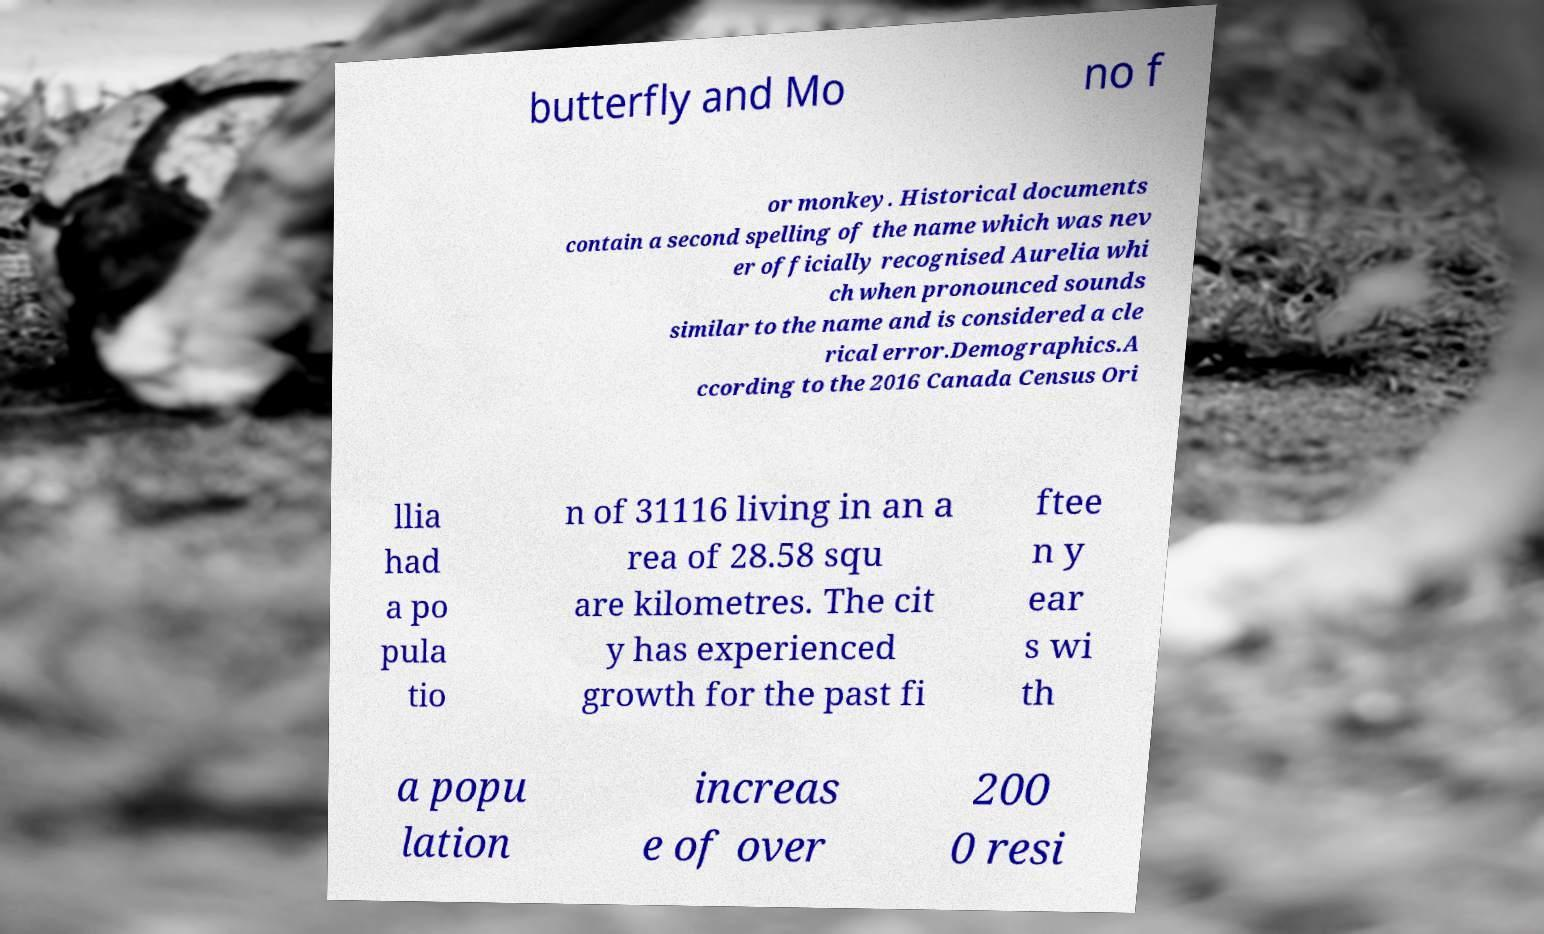There's text embedded in this image that I need extracted. Can you transcribe it verbatim? butterfly and Mo no f or monkey. Historical documents contain a second spelling of the name which was nev er officially recognised Aurelia whi ch when pronounced sounds similar to the name and is considered a cle rical error.Demographics.A ccording to the 2016 Canada Census Ori llia had a po pula tio n of 31116 living in an a rea of 28.58 squ are kilometres. The cit y has experienced growth for the past fi ftee n y ear s wi th a popu lation increas e of over 200 0 resi 